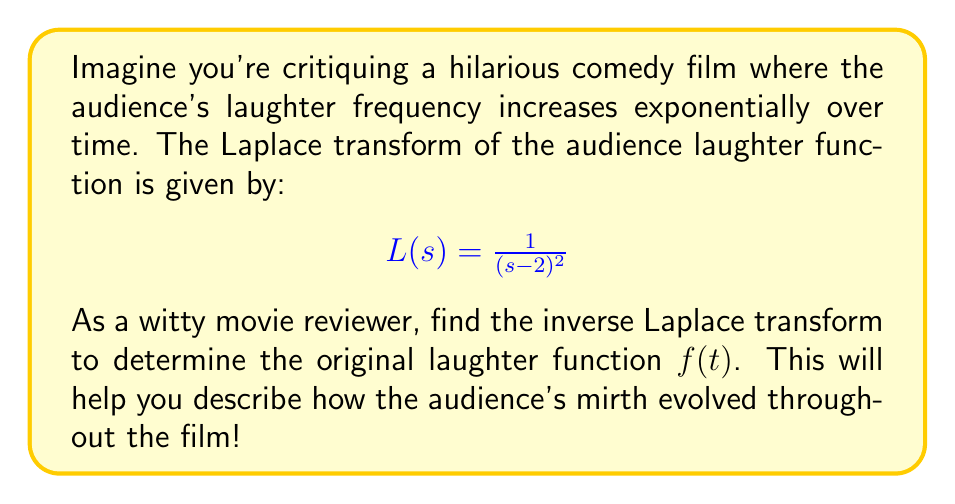Provide a solution to this math problem. Let's approach this step-by-step:

1) We recognize that the given Laplace transform has the form:

   $$\frac{1}{(s-a)^2}$$

   where $a = 2$ in this case.

2) This form corresponds to the following inverse Laplace transform:

   $$\mathcal{L}^{-1}\left\{\frac{1}{(s-a)^2}\right\} = te^{at}$$

3) Substituting $a = 2$, we get:

   $$f(t) = te^{2t}$$

4) To interpret this result humorously:
   - The $t$ factor represents the audience warming up to the jokes over time.
   - The $e^{2t}$ factor shows the exponential increase in laughter, perhaps as the jokes get funnier or the audience becomes more receptive.

5) As $t$ increases, the laughter intensity grows rapidly, potentially leading to side-splitting guffaws by the end of the film!
Answer: $f(t) = te^{2t}$ 